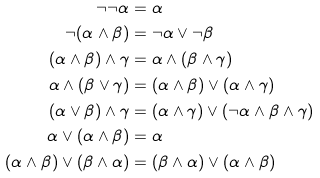<formula> <loc_0><loc_0><loc_500><loc_500>\neg \neg \alpha & = \alpha \\ \neg ( \alpha \wedge \beta ) & = \neg \alpha \vee \neg \beta \\ ( \alpha \wedge \beta ) \wedge \gamma & = \alpha \wedge ( \beta \wedge \gamma ) \\ \alpha \wedge ( \beta \vee \gamma ) & = ( \alpha \wedge \beta ) \vee ( \alpha \wedge \gamma ) \\ ( \alpha \vee \beta ) \wedge \gamma & = ( \alpha \wedge \gamma ) \vee ( \neg \alpha \wedge \beta \wedge \gamma ) \\ \alpha \vee ( \alpha \wedge \beta ) & = \alpha \\ ( \alpha \wedge \beta ) \vee ( \beta \wedge \alpha ) & = ( \beta \wedge \alpha ) \vee ( \alpha \wedge \beta )</formula> 